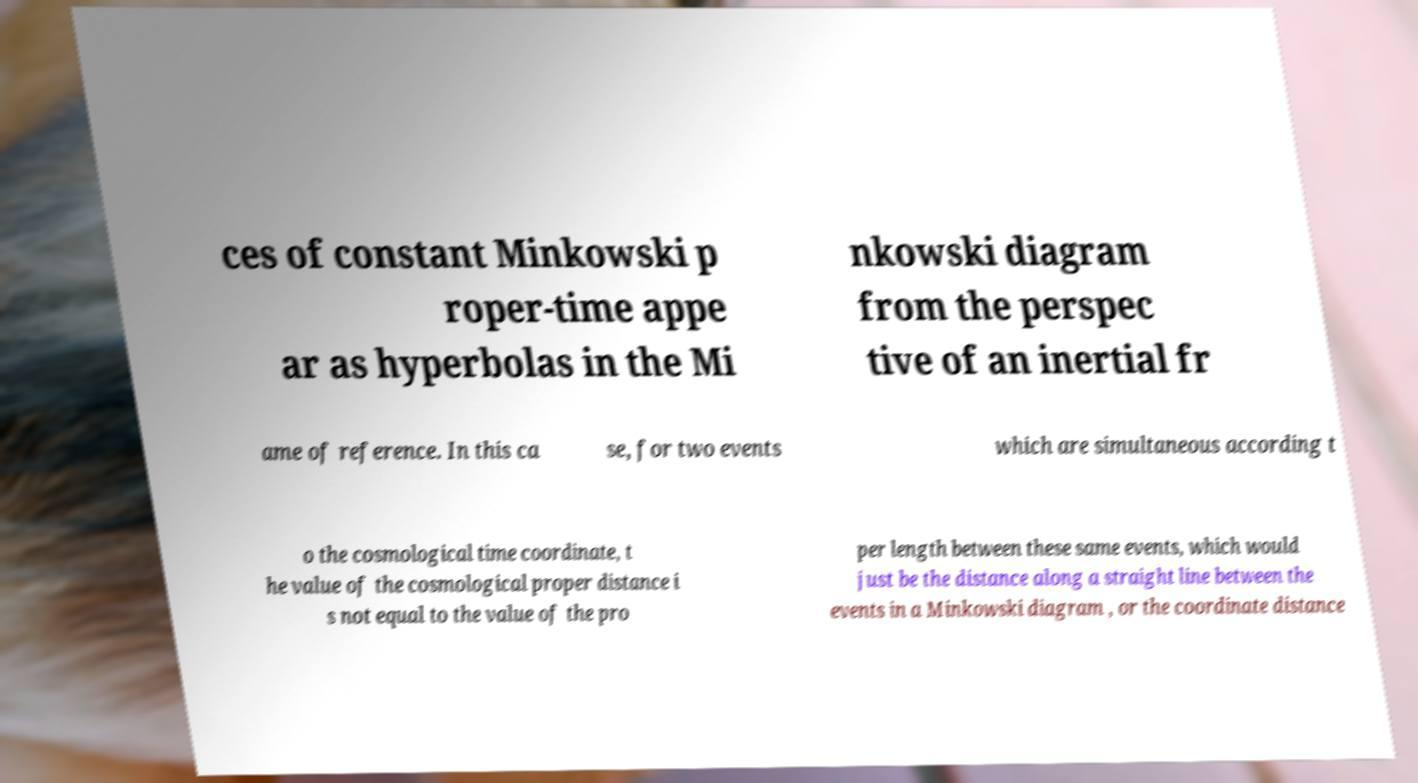There's text embedded in this image that I need extracted. Can you transcribe it verbatim? ces of constant Minkowski p roper-time appe ar as hyperbolas in the Mi nkowski diagram from the perspec tive of an inertial fr ame of reference. In this ca se, for two events which are simultaneous according t o the cosmological time coordinate, t he value of the cosmological proper distance i s not equal to the value of the pro per length between these same events, which would just be the distance along a straight line between the events in a Minkowski diagram , or the coordinate distance 